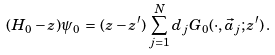Convert formula to latex. <formula><loc_0><loc_0><loc_500><loc_500>( H _ { 0 } - z ) \psi _ { 0 } \, = \, ( z - z ^ { \prime } ) \, \sum _ { j = 1 } ^ { N } d _ { j } G _ { 0 } ( \cdot , \vec { a } _ { j } ; z ^ { \prime } ) \, .</formula> 